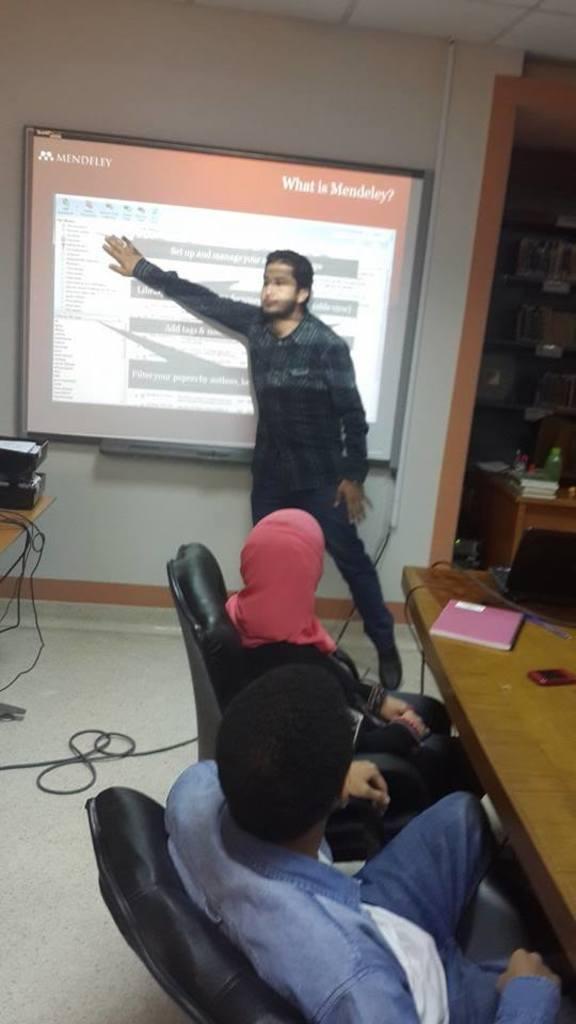In one or two sentences, can you explain what this image depicts? In this picture we can see two persons sitting on the chairs. This is table. On the table there is a book, and a laptop. Here we can see a man who is standing on the floor. This is screen and there is a wall. 